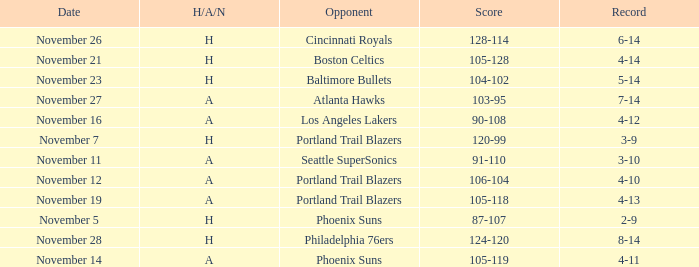On what Date was the Score 105-128? November 21. 